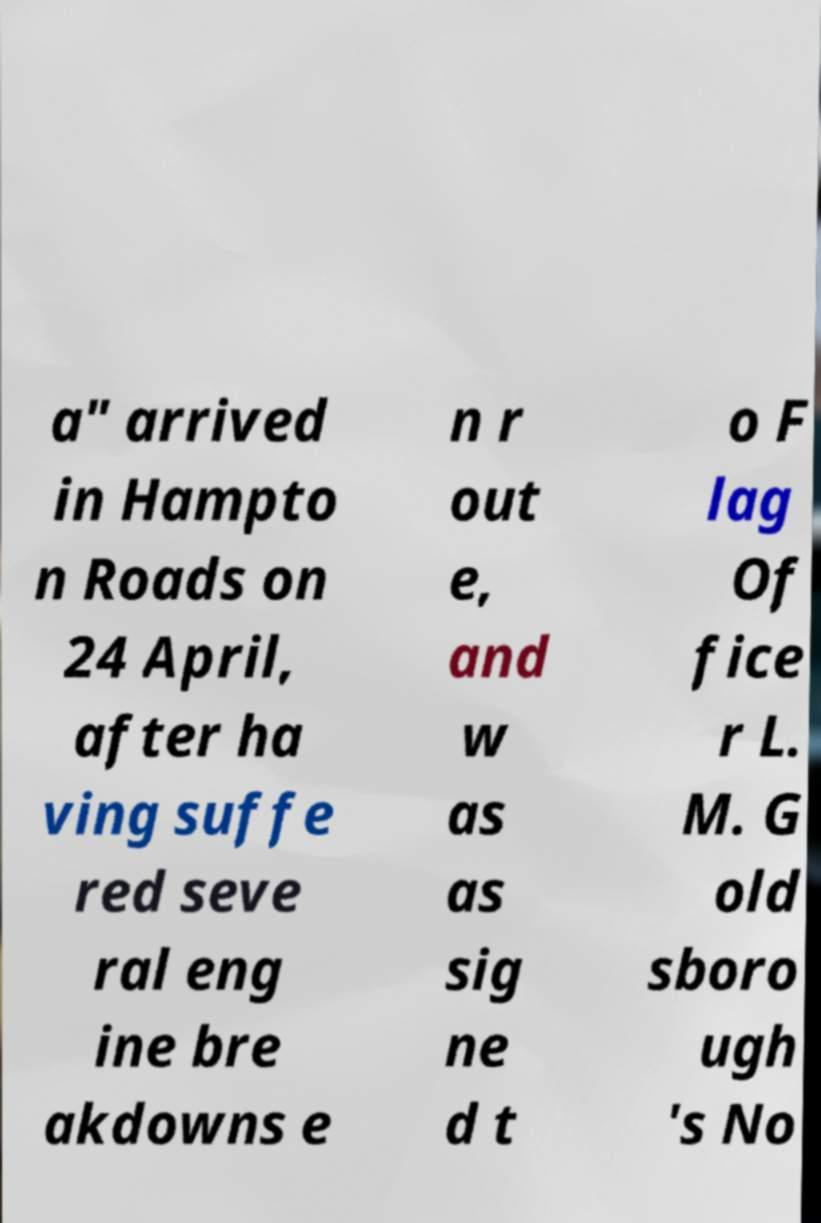I need the written content from this picture converted into text. Can you do that? a" arrived in Hampto n Roads on 24 April, after ha ving suffe red seve ral eng ine bre akdowns e n r out e, and w as as sig ne d t o F lag Of fice r L. M. G old sboro ugh 's No 